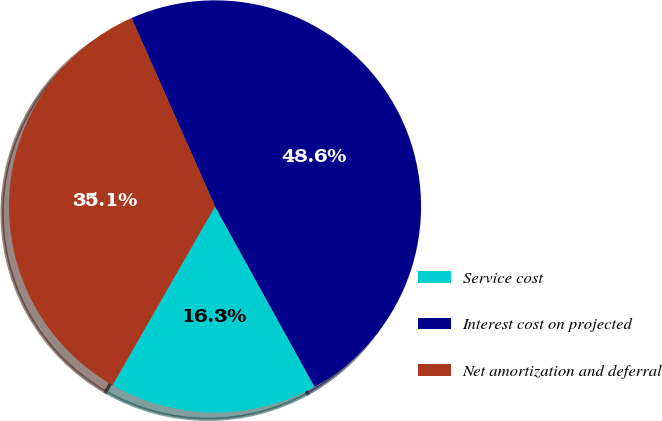Convert chart. <chart><loc_0><loc_0><loc_500><loc_500><pie_chart><fcel>Service cost<fcel>Interest cost on projected<fcel>Net amortization and deferral<nl><fcel>16.31%<fcel>48.61%<fcel>35.08%<nl></chart> 